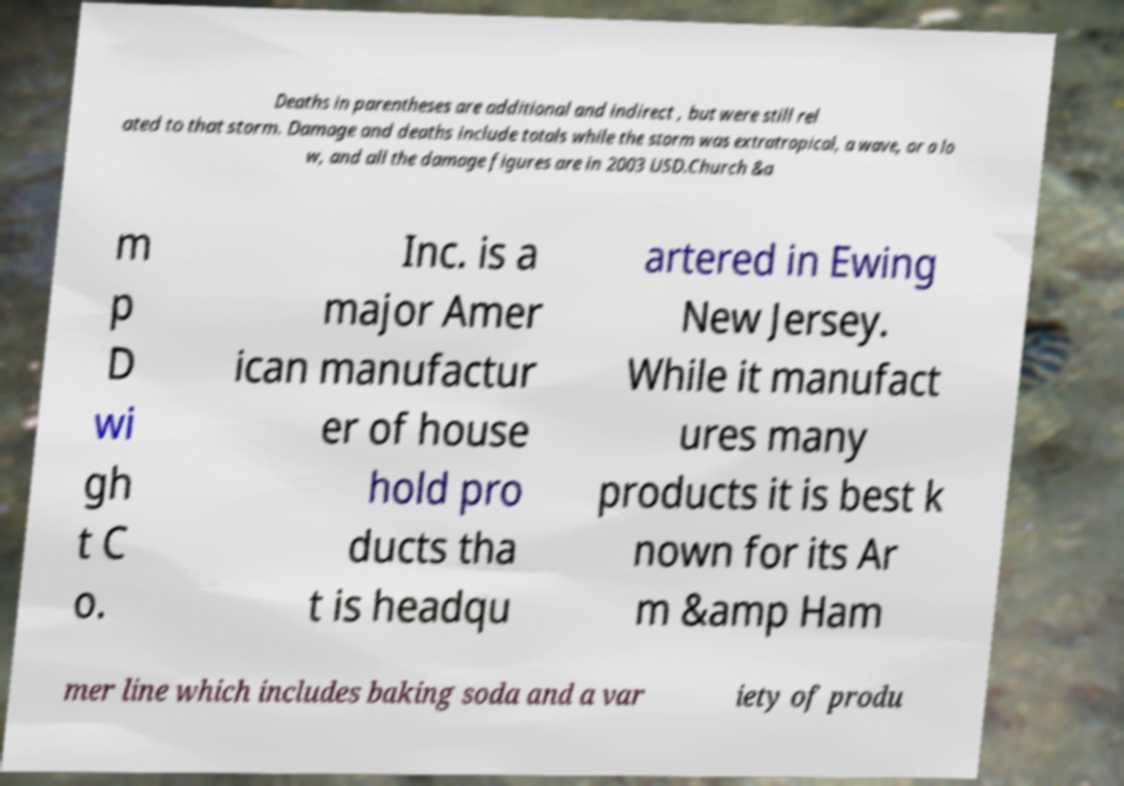Please read and relay the text visible in this image. What does it say? Deaths in parentheses are additional and indirect , but were still rel ated to that storm. Damage and deaths include totals while the storm was extratropical, a wave, or a lo w, and all the damage figures are in 2003 USD.Church &a m p D wi gh t C o. Inc. is a major Amer ican manufactur er of house hold pro ducts tha t is headqu artered in Ewing New Jersey. While it manufact ures many products it is best k nown for its Ar m &amp Ham mer line which includes baking soda and a var iety of produ 